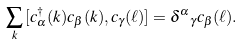<formula> <loc_0><loc_0><loc_500><loc_500>\sum _ { k } { [ } c _ { \alpha } ^ { \dagger } ( k ) c _ { \beta } ( k ) , c _ { \gamma } ( \ell ) { ] } = { \delta ^ { \alpha } } _ { \gamma } c _ { \beta } ( \ell ) .</formula> 